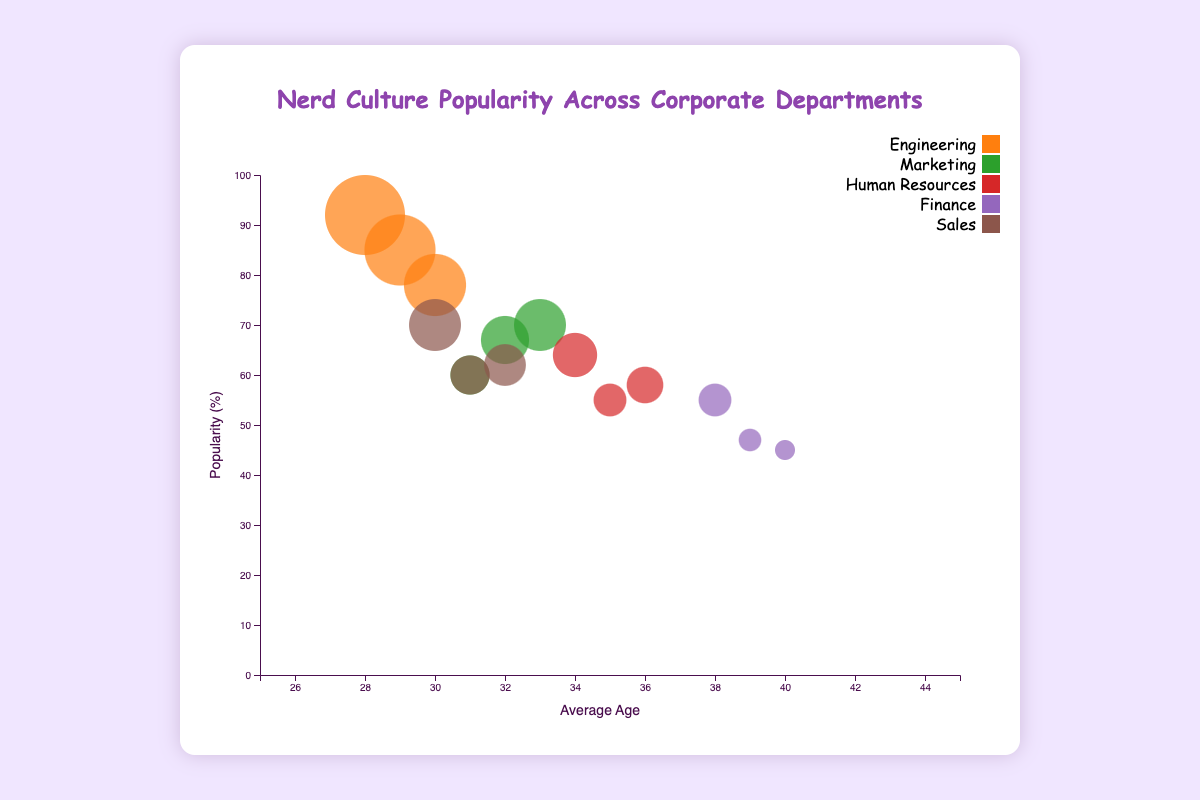What is the title of the chart? The chart's title is prominently displayed at the top-middle of the chart within the container.
Answer: Nerd Culture Popularity Across Corporate Departments What is shown on the x-axis? The x-axis label is found at the bottom of the chart, indicating it represents the "Average Age" of the employees engaging in each nerd culture activity.
Answer: Average Age Which department has the highest popularity in any activity? By examining the y-axis and the circle sizes, we can see that Engineering has the highest popularity for Video Games with a popularity of 92%.
Answer: Engineering What are the popularities of Board Games in Engineering and Sales respectively? Look for the bubble representing Board Games in Engineering and Sales, noting their y-axis (popularity) position: Engineering is at 78% and Sales is at 70%.
Answer: 78%, 70% Which activity has the lowest popularity overall and in which department? Scan the bubbles on the y-axis (popularity) to identify the smallest value, which belongs to Comic-Con in the Finance department with a popularity of 45%.
Answer: Comic-Con, Finance What is the average age of Sales employees engaging in Comic-Con? Locate the bubble representing Comic-Con in the Sales department and note its position along the x-axis, indicating the average age is 31.
Answer: 31 Which two departments have the closest popularity values for Video Games? Compare the Video Games bubbles' y-axis positions for all departments and find that Sales (62%) and Marketing (70%) are the closest.
Answer: Sales and Marketing What is the difference in popularity of Board Games between Human Resources and Finance? Identify the popularity values for Human Resources and Finance for Board Games (64% and 55% respectively), then calculate the difference: 64% - 55% = 9%.
Answer: 9% Which department has the highest average age engaged in any activity? Examine the x-axis positions of all bubbles to find the one farthest to the right, which is Comic-Con in the Finance department with an average age of 40.
Answer: Finance What is the combined popularity of Comic-Con in Engineering and Marketing? Add the popularity values for Comic-Con in Engineering (85%) and Marketing (67%) to get 152%.
Answer: 152% 